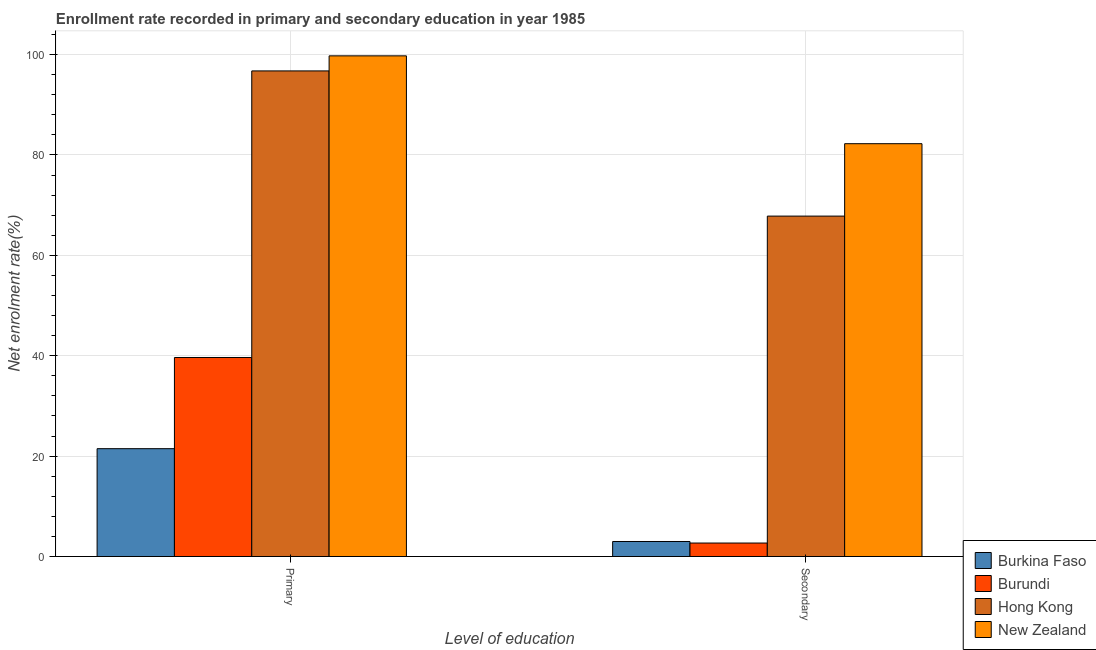How many groups of bars are there?
Provide a short and direct response. 2. How many bars are there on the 2nd tick from the left?
Keep it short and to the point. 4. What is the label of the 1st group of bars from the left?
Provide a short and direct response. Primary. What is the enrollment rate in primary education in Hong Kong?
Offer a terse response. 96.75. Across all countries, what is the maximum enrollment rate in secondary education?
Make the answer very short. 82.25. Across all countries, what is the minimum enrollment rate in secondary education?
Give a very brief answer. 2.69. In which country was the enrollment rate in secondary education maximum?
Offer a terse response. New Zealand. In which country was the enrollment rate in secondary education minimum?
Ensure brevity in your answer.  Burundi. What is the total enrollment rate in primary education in the graph?
Your response must be concise. 257.63. What is the difference between the enrollment rate in secondary education in Hong Kong and that in New Zealand?
Make the answer very short. -14.43. What is the difference between the enrollment rate in primary education in Hong Kong and the enrollment rate in secondary education in Burundi?
Your answer should be compact. 94.06. What is the average enrollment rate in secondary education per country?
Your response must be concise. 38.94. What is the difference between the enrollment rate in primary education and enrollment rate in secondary education in Burundi?
Offer a very short reply. 36.97. In how many countries, is the enrollment rate in primary education greater than 36 %?
Your answer should be very brief. 3. What is the ratio of the enrollment rate in secondary education in New Zealand to that in Hong Kong?
Provide a succinct answer. 1.21. Is the enrollment rate in secondary education in New Zealand less than that in Burundi?
Ensure brevity in your answer.  No. In how many countries, is the enrollment rate in secondary education greater than the average enrollment rate in secondary education taken over all countries?
Ensure brevity in your answer.  2. What does the 3rd bar from the left in Secondary represents?
Make the answer very short. Hong Kong. What does the 4th bar from the right in Secondary represents?
Your answer should be very brief. Burkina Faso. What is the difference between two consecutive major ticks on the Y-axis?
Give a very brief answer. 20. Does the graph contain grids?
Your answer should be very brief. Yes. Where does the legend appear in the graph?
Offer a terse response. Bottom right. How are the legend labels stacked?
Ensure brevity in your answer.  Vertical. What is the title of the graph?
Your answer should be compact. Enrollment rate recorded in primary and secondary education in year 1985. Does "Haiti" appear as one of the legend labels in the graph?
Your response must be concise. No. What is the label or title of the X-axis?
Give a very brief answer. Level of education. What is the label or title of the Y-axis?
Offer a terse response. Net enrolment rate(%). What is the Net enrolment rate(%) in Burkina Faso in Primary?
Your answer should be very brief. 21.48. What is the Net enrolment rate(%) of Burundi in Primary?
Your answer should be very brief. 39.65. What is the Net enrolment rate(%) of Hong Kong in Primary?
Make the answer very short. 96.75. What is the Net enrolment rate(%) in New Zealand in Primary?
Offer a terse response. 99.75. What is the Net enrolment rate(%) of Burkina Faso in Secondary?
Provide a short and direct response. 2.99. What is the Net enrolment rate(%) of Burundi in Secondary?
Give a very brief answer. 2.69. What is the Net enrolment rate(%) of Hong Kong in Secondary?
Ensure brevity in your answer.  67.82. What is the Net enrolment rate(%) of New Zealand in Secondary?
Offer a terse response. 82.25. Across all Level of education, what is the maximum Net enrolment rate(%) in Burkina Faso?
Your answer should be very brief. 21.48. Across all Level of education, what is the maximum Net enrolment rate(%) of Burundi?
Give a very brief answer. 39.65. Across all Level of education, what is the maximum Net enrolment rate(%) of Hong Kong?
Give a very brief answer. 96.75. Across all Level of education, what is the maximum Net enrolment rate(%) in New Zealand?
Ensure brevity in your answer.  99.75. Across all Level of education, what is the minimum Net enrolment rate(%) in Burkina Faso?
Give a very brief answer. 2.99. Across all Level of education, what is the minimum Net enrolment rate(%) of Burundi?
Provide a succinct answer. 2.69. Across all Level of education, what is the minimum Net enrolment rate(%) in Hong Kong?
Your answer should be very brief. 67.82. Across all Level of education, what is the minimum Net enrolment rate(%) of New Zealand?
Keep it short and to the point. 82.25. What is the total Net enrolment rate(%) of Burkina Faso in the graph?
Provide a succinct answer. 24.48. What is the total Net enrolment rate(%) of Burundi in the graph?
Your response must be concise. 42.34. What is the total Net enrolment rate(%) of Hong Kong in the graph?
Provide a short and direct response. 164.57. What is the total Net enrolment rate(%) in New Zealand in the graph?
Your answer should be compact. 182. What is the difference between the Net enrolment rate(%) in Burkina Faso in Primary and that in Secondary?
Provide a succinct answer. 18.49. What is the difference between the Net enrolment rate(%) of Burundi in Primary and that in Secondary?
Your response must be concise. 36.97. What is the difference between the Net enrolment rate(%) of Hong Kong in Primary and that in Secondary?
Keep it short and to the point. 28.93. What is the difference between the Net enrolment rate(%) in New Zealand in Primary and that in Secondary?
Keep it short and to the point. 17.5. What is the difference between the Net enrolment rate(%) in Burkina Faso in Primary and the Net enrolment rate(%) in Burundi in Secondary?
Offer a terse response. 18.8. What is the difference between the Net enrolment rate(%) of Burkina Faso in Primary and the Net enrolment rate(%) of Hong Kong in Secondary?
Provide a succinct answer. -46.34. What is the difference between the Net enrolment rate(%) of Burkina Faso in Primary and the Net enrolment rate(%) of New Zealand in Secondary?
Your answer should be very brief. -60.76. What is the difference between the Net enrolment rate(%) in Burundi in Primary and the Net enrolment rate(%) in Hong Kong in Secondary?
Provide a succinct answer. -28.17. What is the difference between the Net enrolment rate(%) of Burundi in Primary and the Net enrolment rate(%) of New Zealand in Secondary?
Your response must be concise. -42.6. What is the difference between the Net enrolment rate(%) in Hong Kong in Primary and the Net enrolment rate(%) in New Zealand in Secondary?
Offer a terse response. 14.5. What is the average Net enrolment rate(%) in Burkina Faso per Level of education?
Your response must be concise. 12.24. What is the average Net enrolment rate(%) of Burundi per Level of education?
Keep it short and to the point. 21.17. What is the average Net enrolment rate(%) of Hong Kong per Level of education?
Offer a terse response. 82.28. What is the average Net enrolment rate(%) in New Zealand per Level of education?
Your answer should be compact. 91. What is the difference between the Net enrolment rate(%) of Burkina Faso and Net enrolment rate(%) of Burundi in Primary?
Keep it short and to the point. -18.17. What is the difference between the Net enrolment rate(%) in Burkina Faso and Net enrolment rate(%) in Hong Kong in Primary?
Make the answer very short. -75.26. What is the difference between the Net enrolment rate(%) of Burkina Faso and Net enrolment rate(%) of New Zealand in Primary?
Your answer should be compact. -78.26. What is the difference between the Net enrolment rate(%) of Burundi and Net enrolment rate(%) of Hong Kong in Primary?
Provide a succinct answer. -57.09. What is the difference between the Net enrolment rate(%) of Burundi and Net enrolment rate(%) of New Zealand in Primary?
Your response must be concise. -60.09. What is the difference between the Net enrolment rate(%) of Hong Kong and Net enrolment rate(%) of New Zealand in Primary?
Offer a terse response. -3. What is the difference between the Net enrolment rate(%) in Burkina Faso and Net enrolment rate(%) in Burundi in Secondary?
Ensure brevity in your answer.  0.31. What is the difference between the Net enrolment rate(%) in Burkina Faso and Net enrolment rate(%) in Hong Kong in Secondary?
Offer a very short reply. -64.83. What is the difference between the Net enrolment rate(%) of Burkina Faso and Net enrolment rate(%) of New Zealand in Secondary?
Your answer should be compact. -79.25. What is the difference between the Net enrolment rate(%) of Burundi and Net enrolment rate(%) of Hong Kong in Secondary?
Make the answer very short. -65.14. What is the difference between the Net enrolment rate(%) in Burundi and Net enrolment rate(%) in New Zealand in Secondary?
Offer a very short reply. -79.56. What is the difference between the Net enrolment rate(%) in Hong Kong and Net enrolment rate(%) in New Zealand in Secondary?
Ensure brevity in your answer.  -14.43. What is the ratio of the Net enrolment rate(%) of Burkina Faso in Primary to that in Secondary?
Keep it short and to the point. 7.18. What is the ratio of the Net enrolment rate(%) of Burundi in Primary to that in Secondary?
Your answer should be very brief. 14.76. What is the ratio of the Net enrolment rate(%) of Hong Kong in Primary to that in Secondary?
Offer a terse response. 1.43. What is the ratio of the Net enrolment rate(%) in New Zealand in Primary to that in Secondary?
Provide a short and direct response. 1.21. What is the difference between the highest and the second highest Net enrolment rate(%) of Burkina Faso?
Offer a terse response. 18.49. What is the difference between the highest and the second highest Net enrolment rate(%) of Burundi?
Ensure brevity in your answer.  36.97. What is the difference between the highest and the second highest Net enrolment rate(%) in Hong Kong?
Make the answer very short. 28.93. What is the difference between the highest and the second highest Net enrolment rate(%) in New Zealand?
Your response must be concise. 17.5. What is the difference between the highest and the lowest Net enrolment rate(%) of Burkina Faso?
Make the answer very short. 18.49. What is the difference between the highest and the lowest Net enrolment rate(%) in Burundi?
Your answer should be very brief. 36.97. What is the difference between the highest and the lowest Net enrolment rate(%) in Hong Kong?
Offer a terse response. 28.93. What is the difference between the highest and the lowest Net enrolment rate(%) of New Zealand?
Ensure brevity in your answer.  17.5. 